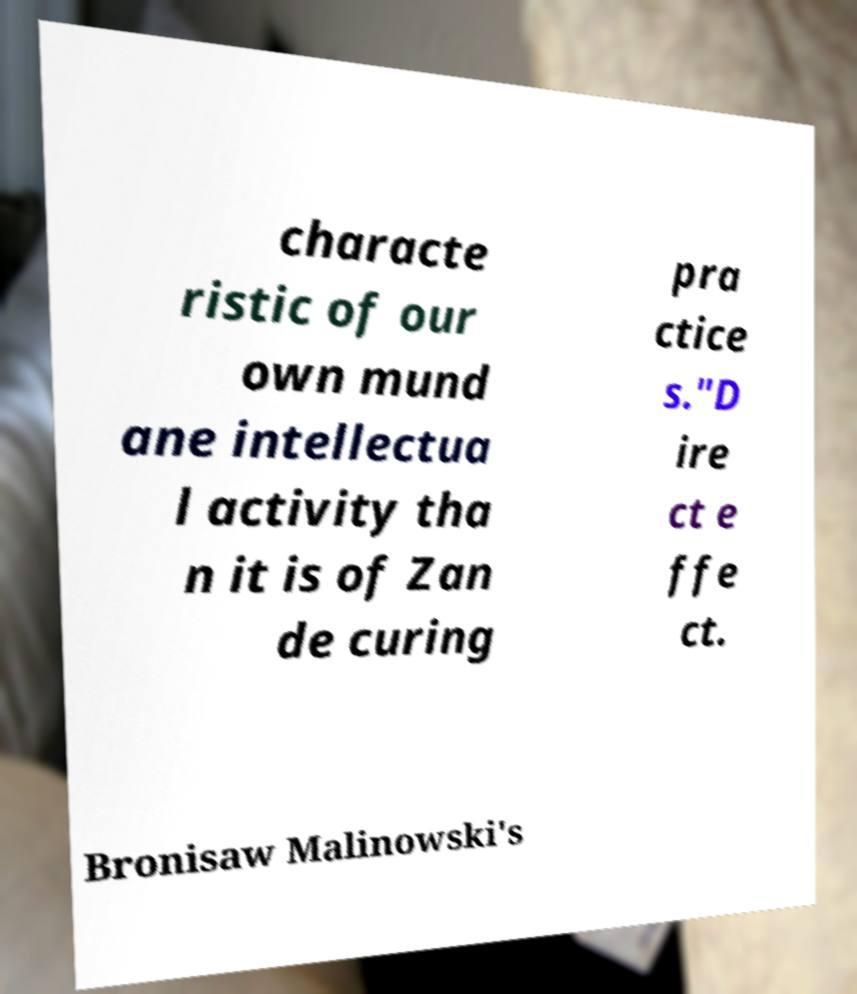For documentation purposes, I need the text within this image transcribed. Could you provide that? characte ristic of our own mund ane intellectua l activity tha n it is of Zan de curing pra ctice s."D ire ct e ffe ct. Bronisaw Malinowski's 